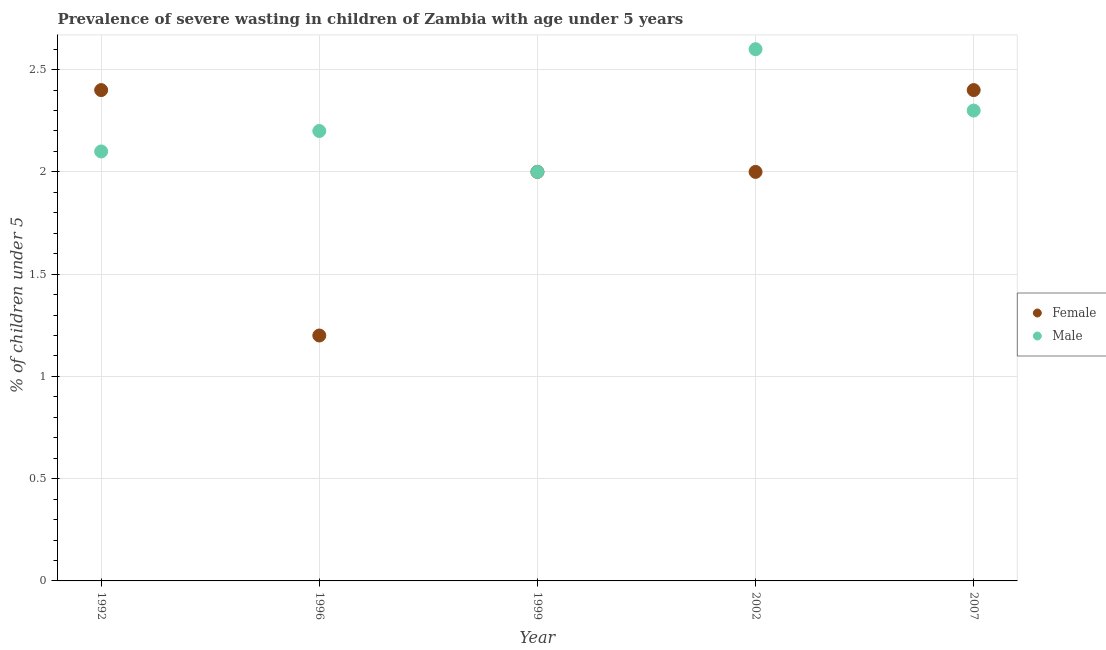Is the number of dotlines equal to the number of legend labels?
Keep it short and to the point. Yes. What is the percentage of undernourished female children in 2002?
Offer a terse response. 2. Across all years, what is the maximum percentage of undernourished female children?
Provide a succinct answer. 2.4. What is the total percentage of undernourished female children in the graph?
Make the answer very short. 10. What is the difference between the percentage of undernourished female children in 1999 and that in 2007?
Ensure brevity in your answer.  -0.4. What is the difference between the percentage of undernourished female children in 2002 and the percentage of undernourished male children in 1996?
Keep it short and to the point. -0.2. What is the average percentage of undernourished female children per year?
Your answer should be compact. 2. In how many years, is the percentage of undernourished female children greater than 0.7 %?
Your answer should be very brief. 5. What is the ratio of the percentage of undernourished female children in 2002 to that in 2007?
Make the answer very short. 0.83. Is the percentage of undernourished male children in 1992 less than that in 2002?
Ensure brevity in your answer.  Yes. Is the difference between the percentage of undernourished female children in 1999 and 2007 greater than the difference between the percentage of undernourished male children in 1999 and 2007?
Keep it short and to the point. No. What is the difference between the highest and the second highest percentage of undernourished female children?
Provide a succinct answer. 0. What is the difference between the highest and the lowest percentage of undernourished male children?
Keep it short and to the point. 0.6. Does the percentage of undernourished female children monotonically increase over the years?
Provide a short and direct response. No. Is the percentage of undernourished female children strictly greater than the percentage of undernourished male children over the years?
Make the answer very short. No. Are the values on the major ticks of Y-axis written in scientific E-notation?
Give a very brief answer. No. Does the graph contain grids?
Provide a short and direct response. Yes. How many legend labels are there?
Your response must be concise. 2. What is the title of the graph?
Provide a succinct answer. Prevalence of severe wasting in children of Zambia with age under 5 years. What is the label or title of the X-axis?
Ensure brevity in your answer.  Year. What is the label or title of the Y-axis?
Give a very brief answer.  % of children under 5. What is the  % of children under 5 of Female in 1992?
Provide a succinct answer. 2.4. What is the  % of children under 5 of Male in 1992?
Keep it short and to the point. 2.1. What is the  % of children under 5 in Female in 1996?
Provide a succinct answer. 1.2. What is the  % of children under 5 of Male in 1996?
Keep it short and to the point. 2.2. What is the  % of children under 5 of Female in 2002?
Offer a very short reply. 2. What is the  % of children under 5 of Male in 2002?
Your answer should be very brief. 2.6. What is the  % of children under 5 in Female in 2007?
Offer a very short reply. 2.4. What is the  % of children under 5 in Male in 2007?
Your answer should be very brief. 2.3. Across all years, what is the maximum  % of children under 5 of Female?
Offer a very short reply. 2.4. Across all years, what is the maximum  % of children under 5 of Male?
Provide a short and direct response. 2.6. Across all years, what is the minimum  % of children under 5 of Female?
Give a very brief answer. 1.2. What is the total  % of children under 5 in Female in the graph?
Offer a terse response. 10. What is the total  % of children under 5 of Male in the graph?
Provide a succinct answer. 11.2. What is the difference between the  % of children under 5 in Female in 1992 and that in 1996?
Your answer should be compact. 1.2. What is the difference between the  % of children under 5 in Male in 1992 and that in 1996?
Make the answer very short. -0.1. What is the difference between the  % of children under 5 of Male in 1992 and that in 2002?
Offer a very short reply. -0.5. What is the difference between the  % of children under 5 in Female in 1992 and that in 2007?
Provide a short and direct response. 0. What is the difference between the  % of children under 5 in Female in 1996 and that in 1999?
Offer a very short reply. -0.8. What is the difference between the  % of children under 5 in Male in 1996 and that in 1999?
Offer a very short reply. 0.2. What is the difference between the  % of children under 5 of Male in 1996 and that in 2002?
Provide a succinct answer. -0.4. What is the difference between the  % of children under 5 of Male in 1996 and that in 2007?
Your answer should be compact. -0.1. What is the difference between the  % of children under 5 in Female in 1999 and that in 2007?
Your response must be concise. -0.4. What is the difference between the  % of children under 5 in Male in 1999 and that in 2007?
Provide a short and direct response. -0.3. What is the difference between the  % of children under 5 in Female in 2002 and that in 2007?
Offer a very short reply. -0.4. What is the difference between the  % of children under 5 of Female in 1992 and the  % of children under 5 of Male in 1999?
Offer a terse response. 0.4. What is the difference between the  % of children under 5 of Female in 1992 and the  % of children under 5 of Male in 2007?
Give a very brief answer. 0.1. What is the difference between the  % of children under 5 in Female in 1996 and the  % of children under 5 in Male in 2002?
Ensure brevity in your answer.  -1.4. What is the difference between the  % of children under 5 of Female in 1996 and the  % of children under 5 of Male in 2007?
Keep it short and to the point. -1.1. What is the difference between the  % of children under 5 in Female in 1999 and the  % of children under 5 in Male in 2007?
Provide a short and direct response. -0.3. What is the average  % of children under 5 in Female per year?
Your response must be concise. 2. What is the average  % of children under 5 of Male per year?
Your answer should be compact. 2.24. In the year 1996, what is the difference between the  % of children under 5 of Female and  % of children under 5 of Male?
Ensure brevity in your answer.  -1. In the year 1999, what is the difference between the  % of children under 5 in Female and  % of children under 5 in Male?
Offer a terse response. 0. In the year 2002, what is the difference between the  % of children under 5 in Female and  % of children under 5 in Male?
Give a very brief answer. -0.6. In the year 2007, what is the difference between the  % of children under 5 in Female and  % of children under 5 in Male?
Give a very brief answer. 0.1. What is the ratio of the  % of children under 5 of Female in 1992 to that in 1996?
Provide a short and direct response. 2. What is the ratio of the  % of children under 5 of Male in 1992 to that in 1996?
Give a very brief answer. 0.95. What is the ratio of the  % of children under 5 of Male in 1992 to that in 1999?
Make the answer very short. 1.05. What is the ratio of the  % of children under 5 of Male in 1992 to that in 2002?
Keep it short and to the point. 0.81. What is the ratio of the  % of children under 5 in Male in 1996 to that in 2002?
Offer a very short reply. 0.85. What is the ratio of the  % of children under 5 in Female in 1996 to that in 2007?
Your answer should be very brief. 0.5. What is the ratio of the  % of children under 5 in Male in 1996 to that in 2007?
Offer a terse response. 0.96. What is the ratio of the  % of children under 5 of Female in 1999 to that in 2002?
Offer a very short reply. 1. What is the ratio of the  % of children under 5 in Male in 1999 to that in 2002?
Make the answer very short. 0.77. What is the ratio of the  % of children under 5 in Female in 1999 to that in 2007?
Ensure brevity in your answer.  0.83. What is the ratio of the  % of children under 5 in Male in 1999 to that in 2007?
Ensure brevity in your answer.  0.87. What is the ratio of the  % of children under 5 in Male in 2002 to that in 2007?
Give a very brief answer. 1.13. What is the difference between the highest and the lowest  % of children under 5 in Female?
Your answer should be very brief. 1.2. What is the difference between the highest and the lowest  % of children under 5 in Male?
Keep it short and to the point. 0.6. 